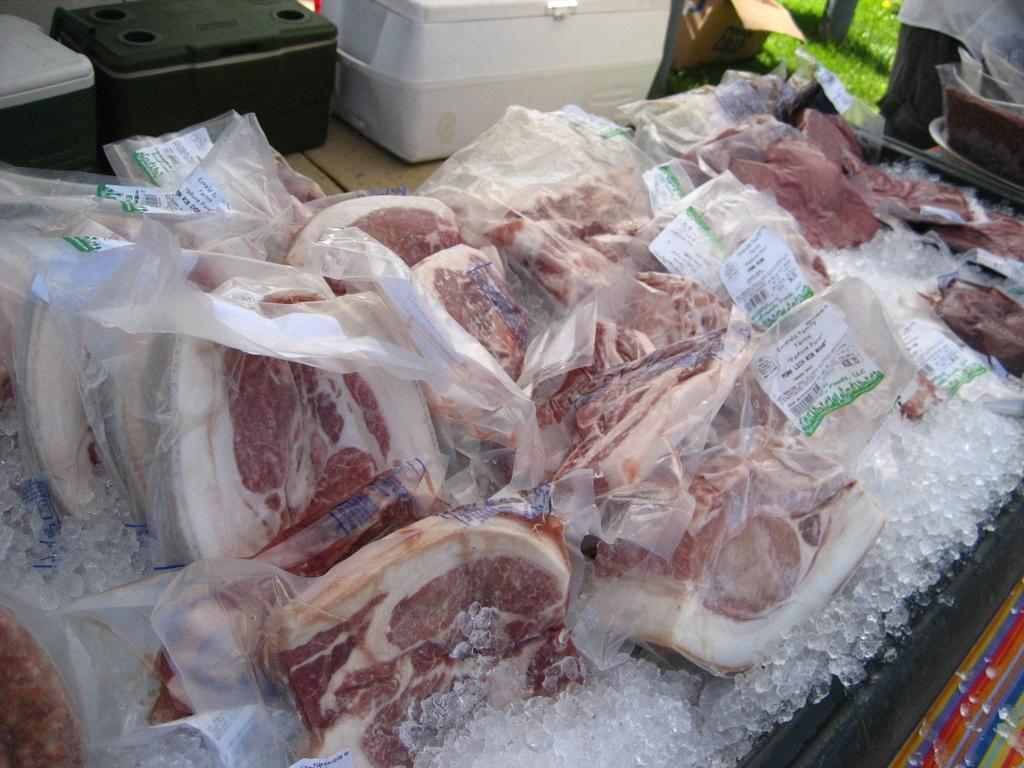What type of food is on the table in the image? There is meat on the table in the image. What other objects are near the meat on the table? There are three boxes beside the meat on the table. What type of quartz is visible in the image? There is no quartz present in the image. What is being carried in the sack in the image? There is no sack present in the image. 